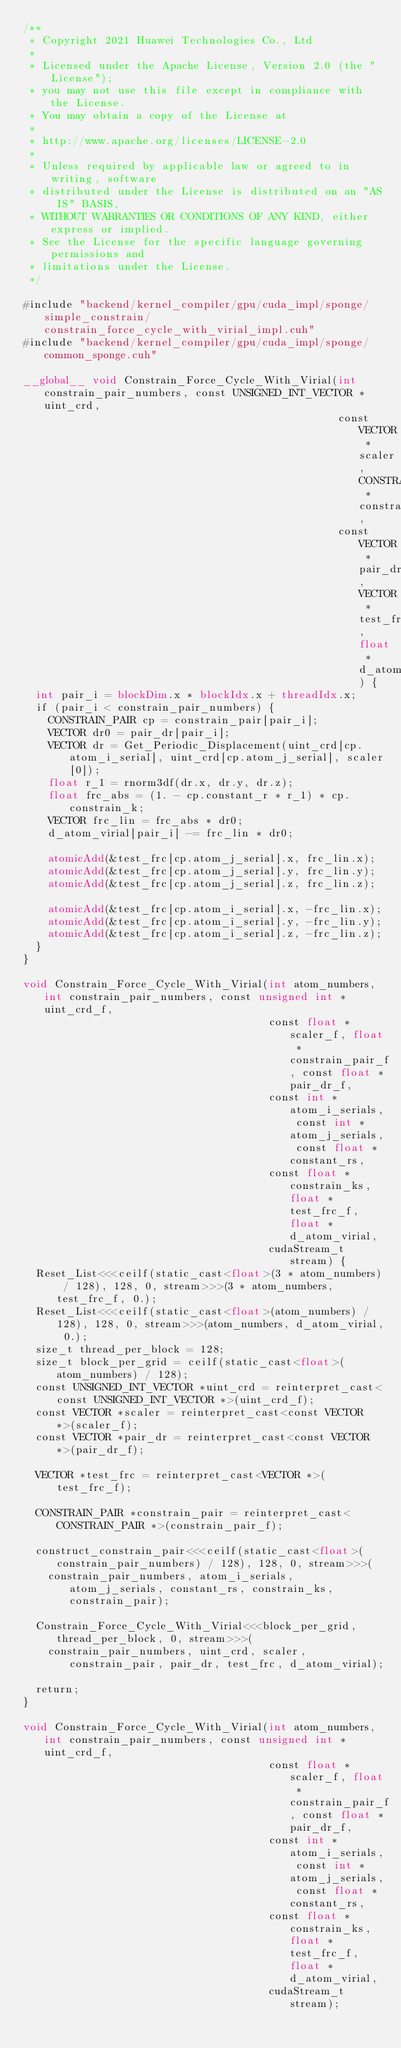<code> <loc_0><loc_0><loc_500><loc_500><_Cuda_>/**
 * Copyright 2021 Huawei Technologies Co., Ltd
 *
 * Licensed under the Apache License, Version 2.0 (the "License");
 * you may not use this file except in compliance with the License.
 * You may obtain a copy of the License at
 *
 * http://www.apache.org/licenses/LICENSE-2.0
 *
 * Unless required by applicable law or agreed to in writing, software
 * distributed under the License is distributed on an "AS IS" BASIS,
 * WITHOUT WARRANTIES OR CONDITIONS OF ANY KIND, either express or implied.
 * See the License for the specific language governing permissions and
 * limitations under the License.
 */

#include "backend/kernel_compiler/gpu/cuda_impl/sponge/simple_constrain/constrain_force_cycle_with_virial_impl.cuh"
#include "backend/kernel_compiler/gpu/cuda_impl/sponge/common_sponge.cuh"

__global__ void Constrain_Force_Cycle_With_Virial(int constrain_pair_numbers, const UNSIGNED_INT_VECTOR *uint_crd,
                                                  const VECTOR *scaler, CONSTRAIN_PAIR *constrain_pair,
                                                  const VECTOR *pair_dr, VECTOR *test_frc, float *d_atom_virial) {
  int pair_i = blockDim.x * blockIdx.x + threadIdx.x;
  if (pair_i < constrain_pair_numbers) {
    CONSTRAIN_PAIR cp = constrain_pair[pair_i];
    VECTOR dr0 = pair_dr[pair_i];
    VECTOR dr = Get_Periodic_Displacement(uint_crd[cp.atom_i_serial], uint_crd[cp.atom_j_serial], scaler[0]);
    float r_1 = rnorm3df(dr.x, dr.y, dr.z);
    float frc_abs = (1. - cp.constant_r * r_1) * cp.constrain_k;
    VECTOR frc_lin = frc_abs * dr0;
    d_atom_virial[pair_i] -= frc_lin * dr0;

    atomicAdd(&test_frc[cp.atom_j_serial].x, frc_lin.x);
    atomicAdd(&test_frc[cp.atom_j_serial].y, frc_lin.y);
    atomicAdd(&test_frc[cp.atom_j_serial].z, frc_lin.z);

    atomicAdd(&test_frc[cp.atom_i_serial].x, -frc_lin.x);
    atomicAdd(&test_frc[cp.atom_i_serial].y, -frc_lin.y);
    atomicAdd(&test_frc[cp.atom_i_serial].z, -frc_lin.z);
  }
}

void Constrain_Force_Cycle_With_Virial(int atom_numbers, int constrain_pair_numbers, const unsigned int *uint_crd_f,
                                       const float *scaler_f, float *constrain_pair_f, const float *pair_dr_f,
                                       const int *atom_i_serials, const int *atom_j_serials, const float *constant_rs,
                                       const float *constrain_ks, float *test_frc_f, float *d_atom_virial,
                                       cudaStream_t stream) {
  Reset_List<<<ceilf(static_cast<float>(3 * atom_numbers) / 128), 128, 0, stream>>>(3 * atom_numbers, test_frc_f, 0.);
  Reset_List<<<ceilf(static_cast<float>(atom_numbers) / 128), 128, 0, stream>>>(atom_numbers, d_atom_virial, 0.);
  size_t thread_per_block = 128;
  size_t block_per_grid = ceilf(static_cast<float>(atom_numbers) / 128);
  const UNSIGNED_INT_VECTOR *uint_crd = reinterpret_cast<const UNSIGNED_INT_VECTOR *>(uint_crd_f);
  const VECTOR *scaler = reinterpret_cast<const VECTOR *>(scaler_f);
  const VECTOR *pair_dr = reinterpret_cast<const VECTOR *>(pair_dr_f);

  VECTOR *test_frc = reinterpret_cast<VECTOR *>(test_frc_f);

  CONSTRAIN_PAIR *constrain_pair = reinterpret_cast<CONSTRAIN_PAIR *>(constrain_pair_f);

  construct_constrain_pair<<<ceilf(static_cast<float>(constrain_pair_numbers) / 128), 128, 0, stream>>>(
    constrain_pair_numbers, atom_i_serials, atom_j_serials, constant_rs, constrain_ks, constrain_pair);

  Constrain_Force_Cycle_With_Virial<<<block_per_grid, thread_per_block, 0, stream>>>(
    constrain_pair_numbers, uint_crd, scaler, constrain_pair, pair_dr, test_frc, d_atom_virial);

  return;
}

void Constrain_Force_Cycle_With_Virial(int atom_numbers, int constrain_pair_numbers, const unsigned int *uint_crd_f,
                                       const float *scaler_f, float *constrain_pair_f, const float *pair_dr_f,
                                       const int *atom_i_serials, const int *atom_j_serials, const float *constant_rs,
                                       const float *constrain_ks, float *test_frc_f, float *d_atom_virial,
                                       cudaStream_t stream);
</code> 